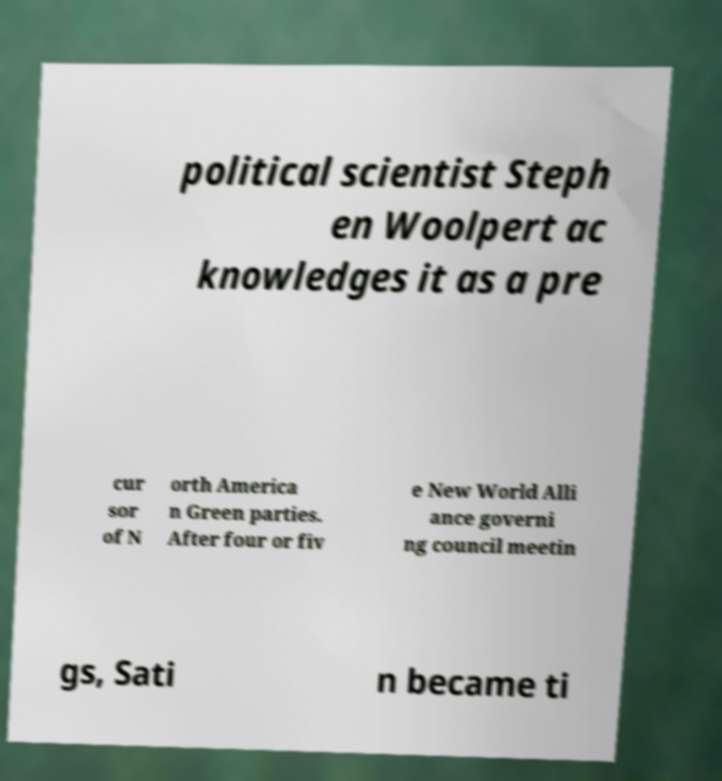Please identify and transcribe the text found in this image. political scientist Steph en Woolpert ac knowledges it as a pre cur sor of N orth America n Green parties. After four or fiv e New World Alli ance governi ng council meetin gs, Sati n became ti 